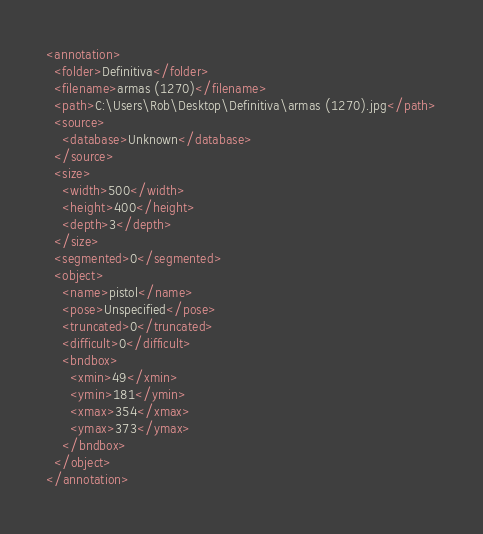<code> <loc_0><loc_0><loc_500><loc_500><_XML_><annotation>
  <folder>Definitiva</folder>
  <filename>armas (1270)</filename>
  <path>C:\Users\Rob\Desktop\Definitiva\armas (1270).jpg</path>
  <source>
    <database>Unknown</database>
  </source>
  <size>
    <width>500</width>
    <height>400</height>
    <depth>3</depth>
  </size>
  <segmented>0</segmented>
  <object>
    <name>pistol</name>
    <pose>Unspecified</pose>
    <truncated>0</truncated>
    <difficult>0</difficult>
    <bndbox>
      <xmin>49</xmin>
      <ymin>181</ymin>
      <xmax>354</xmax>
      <ymax>373</ymax>
    </bndbox>
  </object>
</annotation>
</code> 